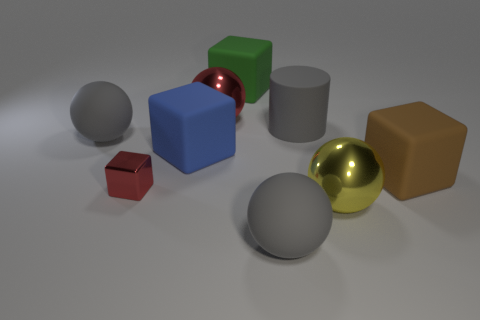What shape is the big metallic thing that is the same color as the metal cube?
Provide a succinct answer. Sphere. What shape is the big gray matte thing that is right of the large gray object in front of the blue thing that is behind the large brown thing?
Provide a short and direct response. Cylinder. Is the number of big blue matte cubes greater than the number of large blue metallic things?
Your answer should be very brief. Yes. There is another blue thing that is the same shape as the tiny shiny thing; what is its material?
Keep it short and to the point. Rubber. Do the large brown object and the large green block have the same material?
Your response must be concise. Yes. Are there more objects that are on the left side of the big brown thing than large gray matte cubes?
Provide a succinct answer. Yes. There is a large object that is behind the big metallic ball that is behind the big thing that is left of the blue rubber object; what is its material?
Ensure brevity in your answer.  Rubber. What number of objects are either blue matte things or shiny balls that are behind the yellow metallic sphere?
Provide a short and direct response. 2. There is a big matte thing that is on the left side of the tiny thing; does it have the same color as the metallic cube?
Your response must be concise. No. Is the number of gray rubber cylinders that are in front of the rubber cylinder greater than the number of red cubes that are in front of the large green rubber block?
Offer a terse response. No. 